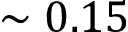<formula> <loc_0><loc_0><loc_500><loc_500>\sim 0 . 1 5</formula> 